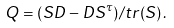Convert formula to latex. <formula><loc_0><loc_0><loc_500><loc_500>Q = { ( S D - D S ^ { \tau } ) } / { t r ( S ) } \, .</formula> 